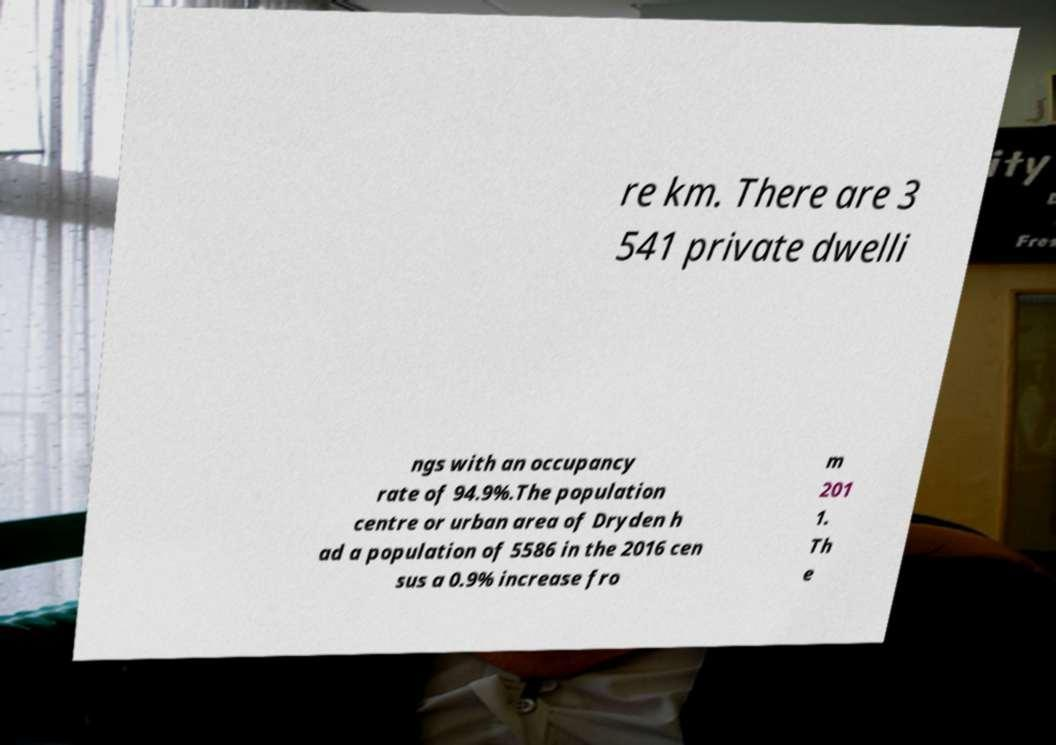I need the written content from this picture converted into text. Can you do that? re km. There are 3 541 private dwelli ngs with an occupancy rate of 94.9%.The population centre or urban area of Dryden h ad a population of 5586 in the 2016 cen sus a 0.9% increase fro m 201 1. Th e 